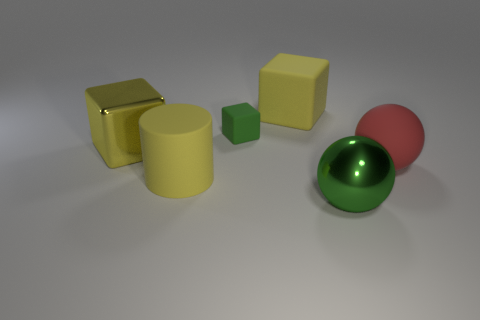What size is the metallic object that is the same color as the small rubber object?
Give a very brief answer. Large. What number of objects are small blocks or large red matte spheres?
Keep it short and to the point. 2. How many other objects are the same size as the green metallic sphere?
Your answer should be compact. 4. There is a rubber cylinder; is it the same color as the metallic thing left of the green cube?
Ensure brevity in your answer.  Yes. What number of cubes are yellow metallic things or big gray shiny things?
Offer a very short reply. 1. Are there any other things that have the same color as the metal cube?
Provide a short and direct response. Yes. What material is the big yellow block behind the shiny object to the left of the green shiny thing?
Offer a very short reply. Rubber. Does the green cube have the same material as the sphere behind the yellow cylinder?
Make the answer very short. Yes. What number of things are either objects to the right of the metallic cube or big red spheres?
Provide a succinct answer. 5. Are there any tiny matte objects of the same color as the big shiny sphere?
Ensure brevity in your answer.  Yes. 